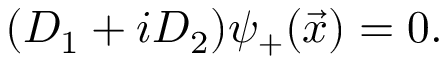Convert formula to latex. <formula><loc_0><loc_0><loc_500><loc_500>( D _ { 1 } + i D _ { 2 } ) { \psi } _ { + } ( \vec { x } ) = 0 .</formula> 